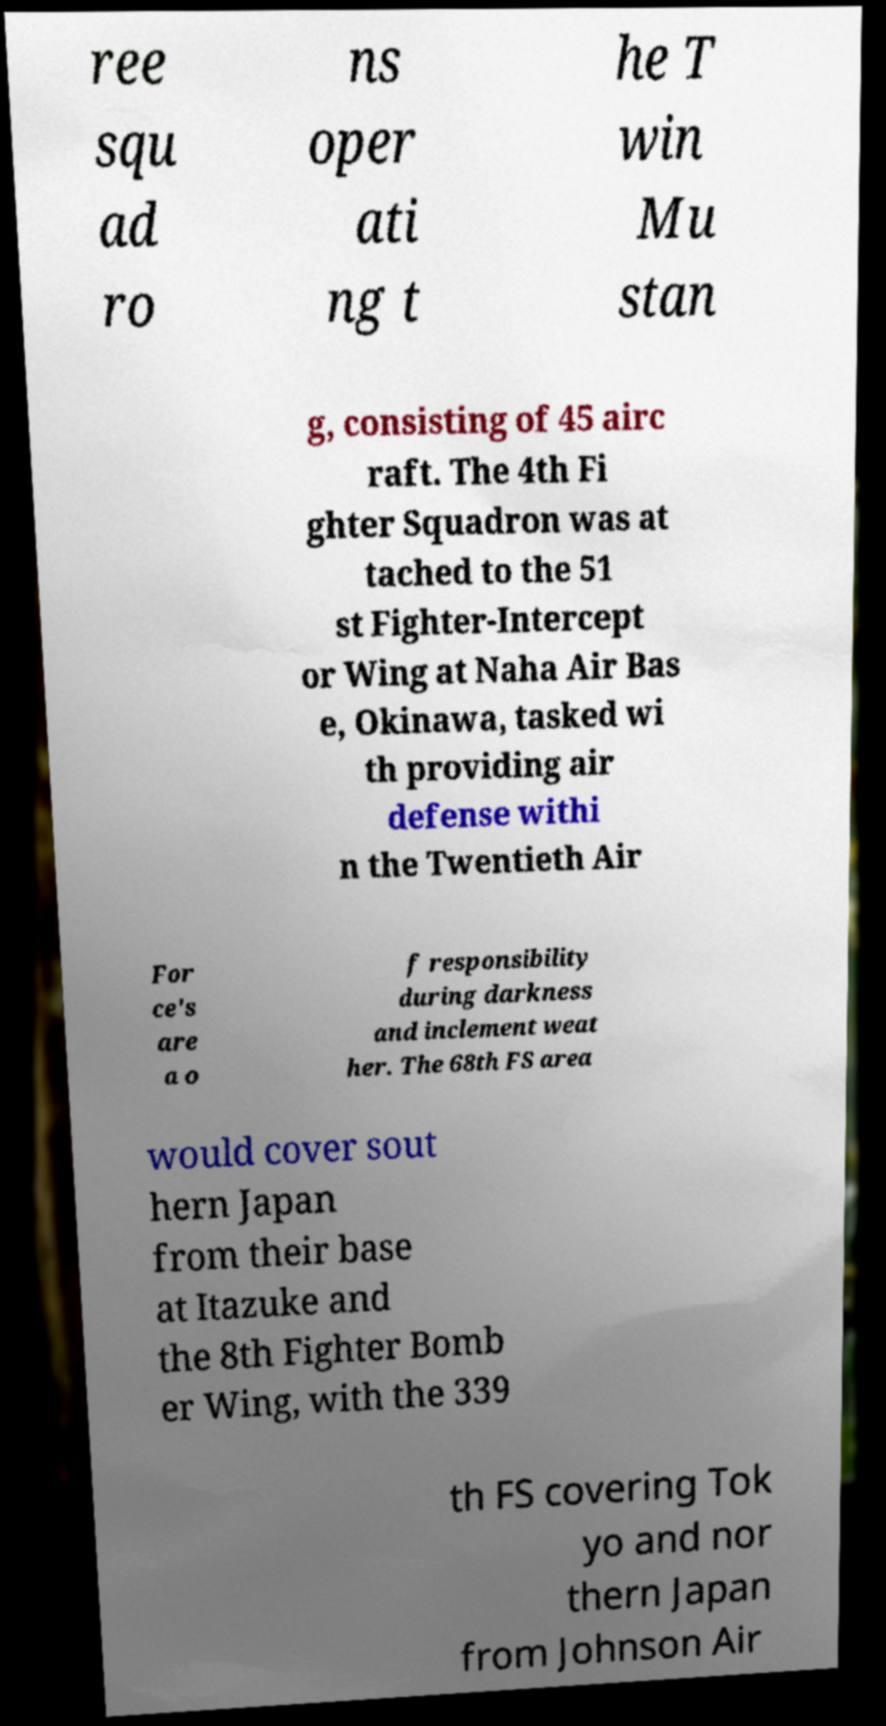Please identify and transcribe the text found in this image. ree squ ad ro ns oper ati ng t he T win Mu stan g, consisting of 45 airc raft. The 4th Fi ghter Squadron was at tached to the 51 st Fighter-Intercept or Wing at Naha Air Bas e, Okinawa, tasked wi th providing air defense withi n the Twentieth Air For ce's are a o f responsibility during darkness and inclement weat her. The 68th FS area would cover sout hern Japan from their base at Itazuke and the 8th Fighter Bomb er Wing, with the 339 th FS covering Tok yo and nor thern Japan from Johnson Air 